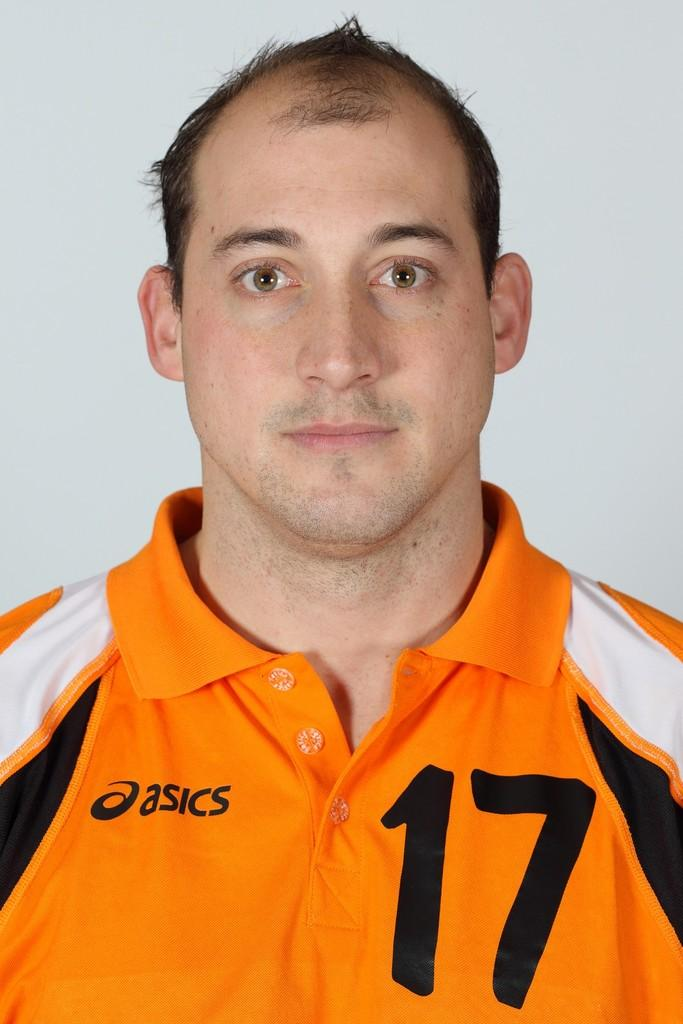<image>
Describe the image concisely. A man wearing a polo-style jersey from asics, number 17. 